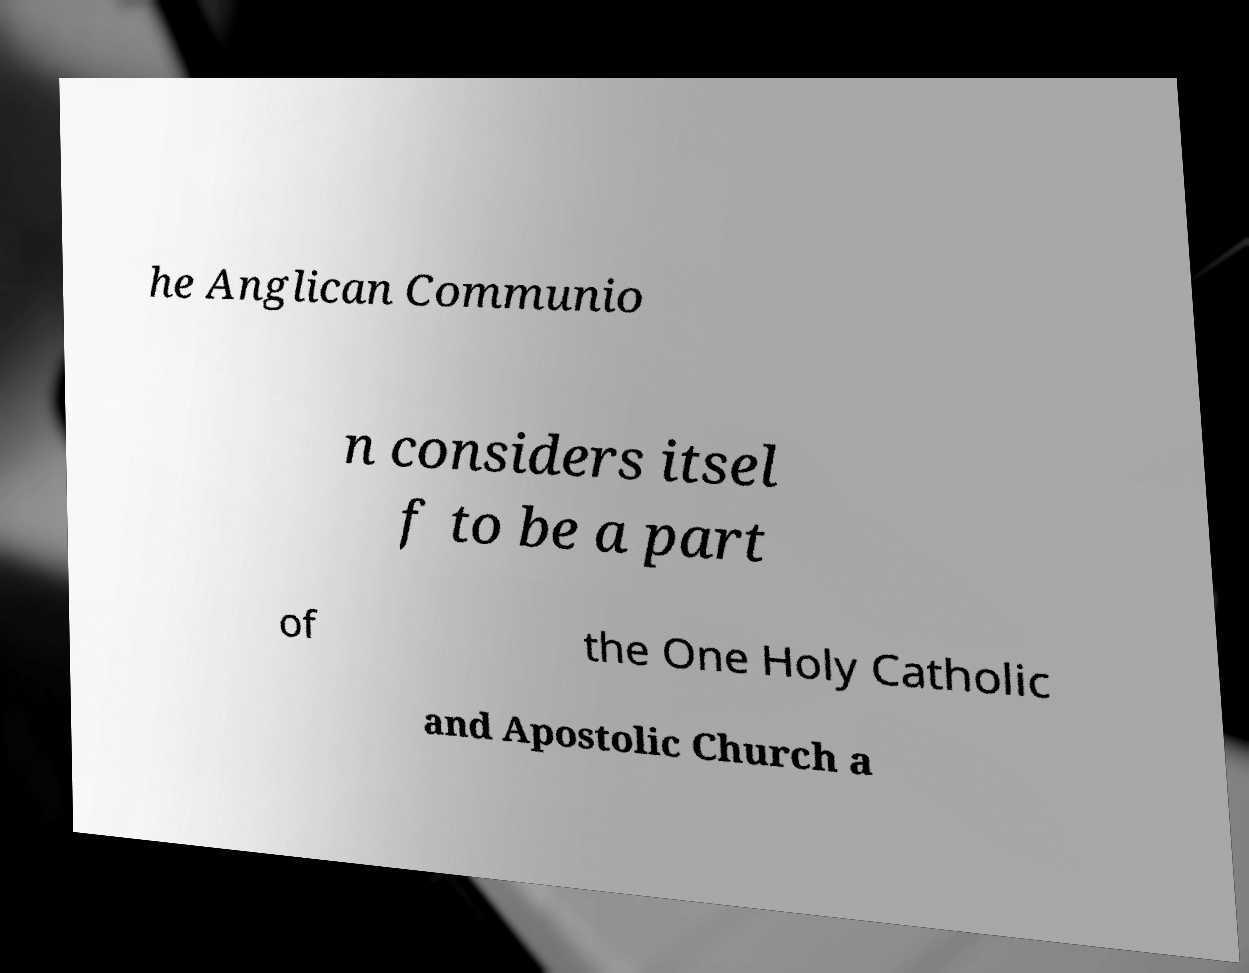Please read and relay the text visible in this image. What does it say? he Anglican Communio n considers itsel f to be a part of the One Holy Catholic and Apostolic Church a 